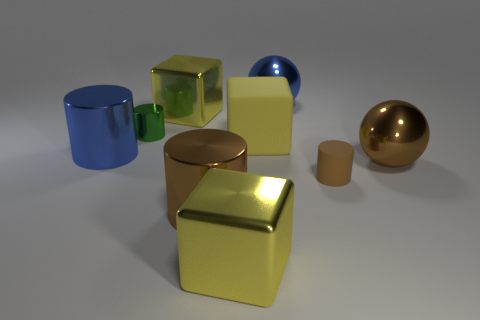Are there more large yellow shiny blocks than brown rubber cylinders?
Ensure brevity in your answer.  Yes. There is a brown object that is both on the left side of the brown shiny sphere and right of the yellow rubber object; what material is it?
Your answer should be very brief. Rubber. How many other objects are there of the same material as the small brown thing?
Offer a very short reply. 1. What number of metal objects are the same color as the matte block?
Your answer should be very brief. 2. There is a green cylinder that is to the left of the yellow shiny object in front of the large cylinder on the left side of the tiny shiny cylinder; what size is it?
Your response must be concise. Small. What number of rubber things are large objects or large blocks?
Ensure brevity in your answer.  1. There is a small green object; is it the same shape as the small object right of the yellow matte block?
Make the answer very short. Yes. Is the number of brown things on the right side of the brown metallic cylinder greater than the number of large metallic cubes that are in front of the green object?
Your answer should be compact. Yes. Is there anything else that has the same color as the tiny metal cylinder?
Provide a short and direct response. No. Are there any large shiny things on the right side of the large yellow shiny block behind the large brown metallic ball right of the matte cylinder?
Ensure brevity in your answer.  Yes. 